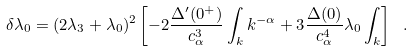<formula> <loc_0><loc_0><loc_500><loc_500>\delta \lambda _ { 0 } = ( 2 \lambda _ { 3 } + \lambda _ { 0 } ) ^ { 2 } \left [ - 2 \frac { \Delta ^ { \prime } ( 0 ^ { + } ) } { c _ { \alpha } ^ { 3 } } \int _ { k } k ^ { - \alpha } + 3 \frac { \Delta ( 0 ) } { c _ { \alpha } ^ { 4 } } \lambda _ { 0 } \int _ { k } \right ] \ .</formula> 